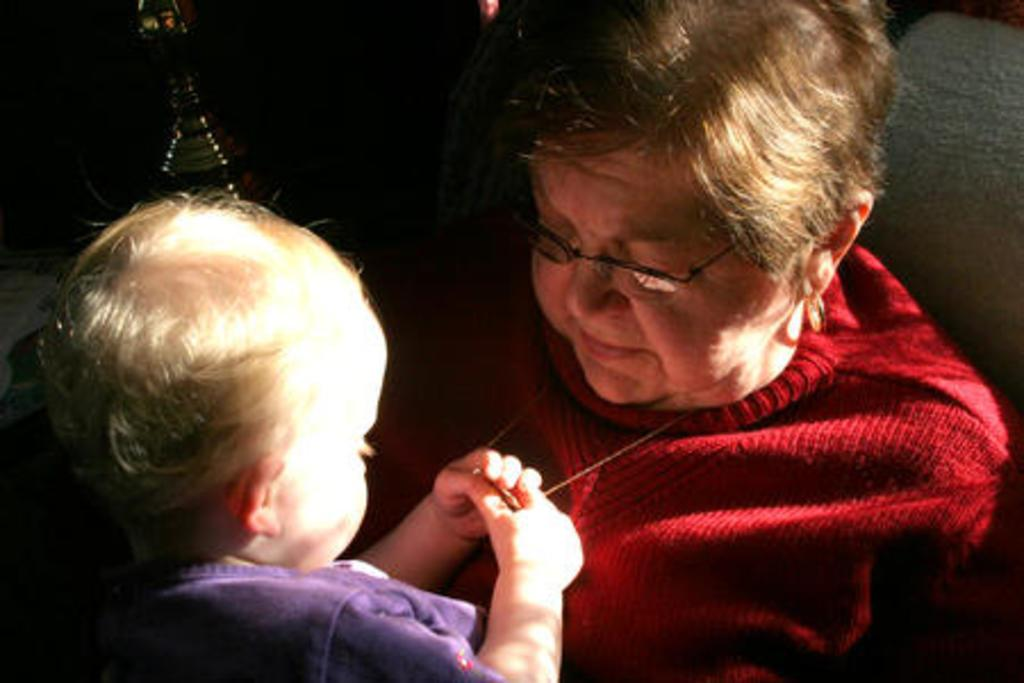Who is present in the image? There is a woman and a child in the image. What is the woman wearing? The woman is wearing spectacles. What is the woman's facial expression? The woman is smiling. What is the child holding in the image? The child is holding a locket. What can be observed about the background of the image? The background of the image is dark. What type of hose is being used by the woman in the image? There is no hose present in the image. What offer is the woman making to the child in the image? There is no offer being made in the image; the woman is simply smiling. 